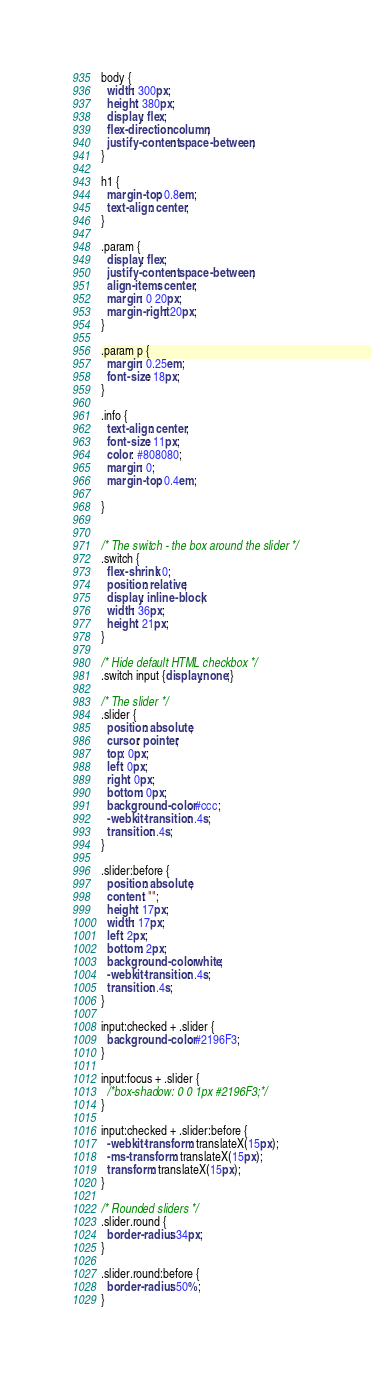Convert code to text. <code><loc_0><loc_0><loc_500><loc_500><_CSS_>body {
  width: 300px;
  height: 380px;
  display: flex;
  flex-direction: column;
  justify-content: space-between;
}

h1 {
  margin-top: 0.8em;
  text-align: center;
}

.param {
  display: flex;
  justify-content: space-between;
  align-items: center;
  margin: 0 20px;
  margin-right: 20px;
}

.param p {
  margin: 0.25em;
  font-size: 18px;
}

.info {
  text-align: center;
  font-size: 11px;
  color: #808080;
  margin: 0;
  margin-top: 0.4em;

}


/* The switch - the box around the slider */
.switch {
  flex-shrink: 0;
  position: relative;
  display: inline-block;
  width: 36px;
  height: 21px;
}

/* Hide default HTML checkbox */
.switch input {display:none;}

/* The slider */
.slider {
  position: absolute;
  cursor: pointer;
  top: 0px;
  left: 0px;
  right: 0px;
  bottom: 0px;
  background-color: #ccc;
  -webkit-transition: .4s;
  transition: .4s;
}

.slider:before {
  position: absolute;
  content: "";
  height: 17px;
  width: 17px;
  left: 2px;
  bottom: 2px;
  background-color: white;
  -webkit-transition: .4s;
  transition: .4s;
}

input:checked + .slider {
  background-color: #2196F3;
}

input:focus + .slider {
  /*box-shadow: 0 0 1px #2196F3;*/
}

input:checked + .slider:before {
  -webkit-transform: translateX(15px);
  -ms-transform: translateX(15px);
  transform: translateX(15px);
}

/* Rounded sliders */
.slider.round {
  border-radius: 34px;
}

.slider.round:before {
  border-radius: 50%;
}
</code> 